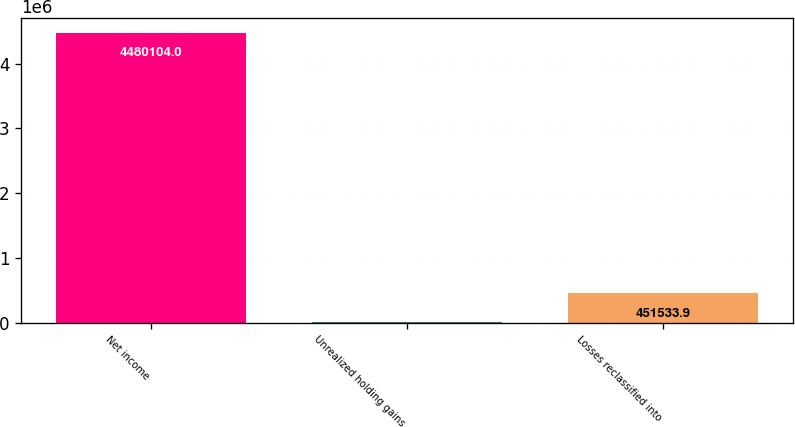Convert chart. <chart><loc_0><loc_0><loc_500><loc_500><bar_chart><fcel>Net income<fcel>Unrealized holding gains<fcel>Losses reclassified into<nl><fcel>4.4801e+06<fcel>3915<fcel>451534<nl></chart> 